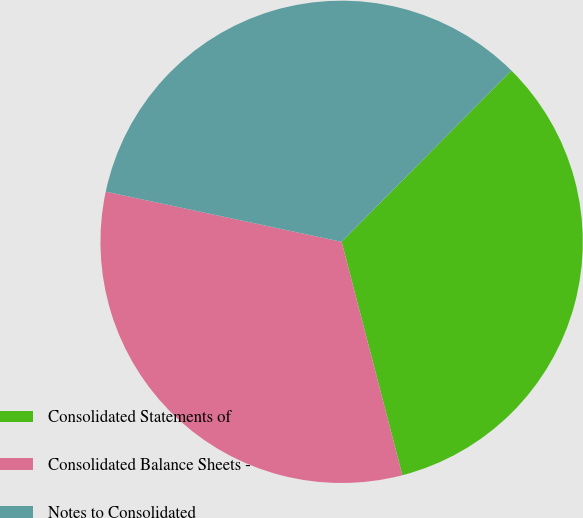Convert chart. <chart><loc_0><loc_0><loc_500><loc_500><pie_chart><fcel>Consolidated Statements of<fcel>Consolidated Balance Sheets -<fcel>Notes to Consolidated<nl><fcel>33.52%<fcel>32.39%<fcel>34.09%<nl></chart> 